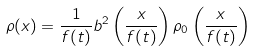Convert formula to latex. <formula><loc_0><loc_0><loc_500><loc_500>\rho ( x ) = \frac { 1 } { f ( t ) } b ^ { 2 } \left ( \frac { x } { f ( t ) } \right ) \rho _ { 0 } \left ( \frac { x } { f ( t ) } \right )</formula> 